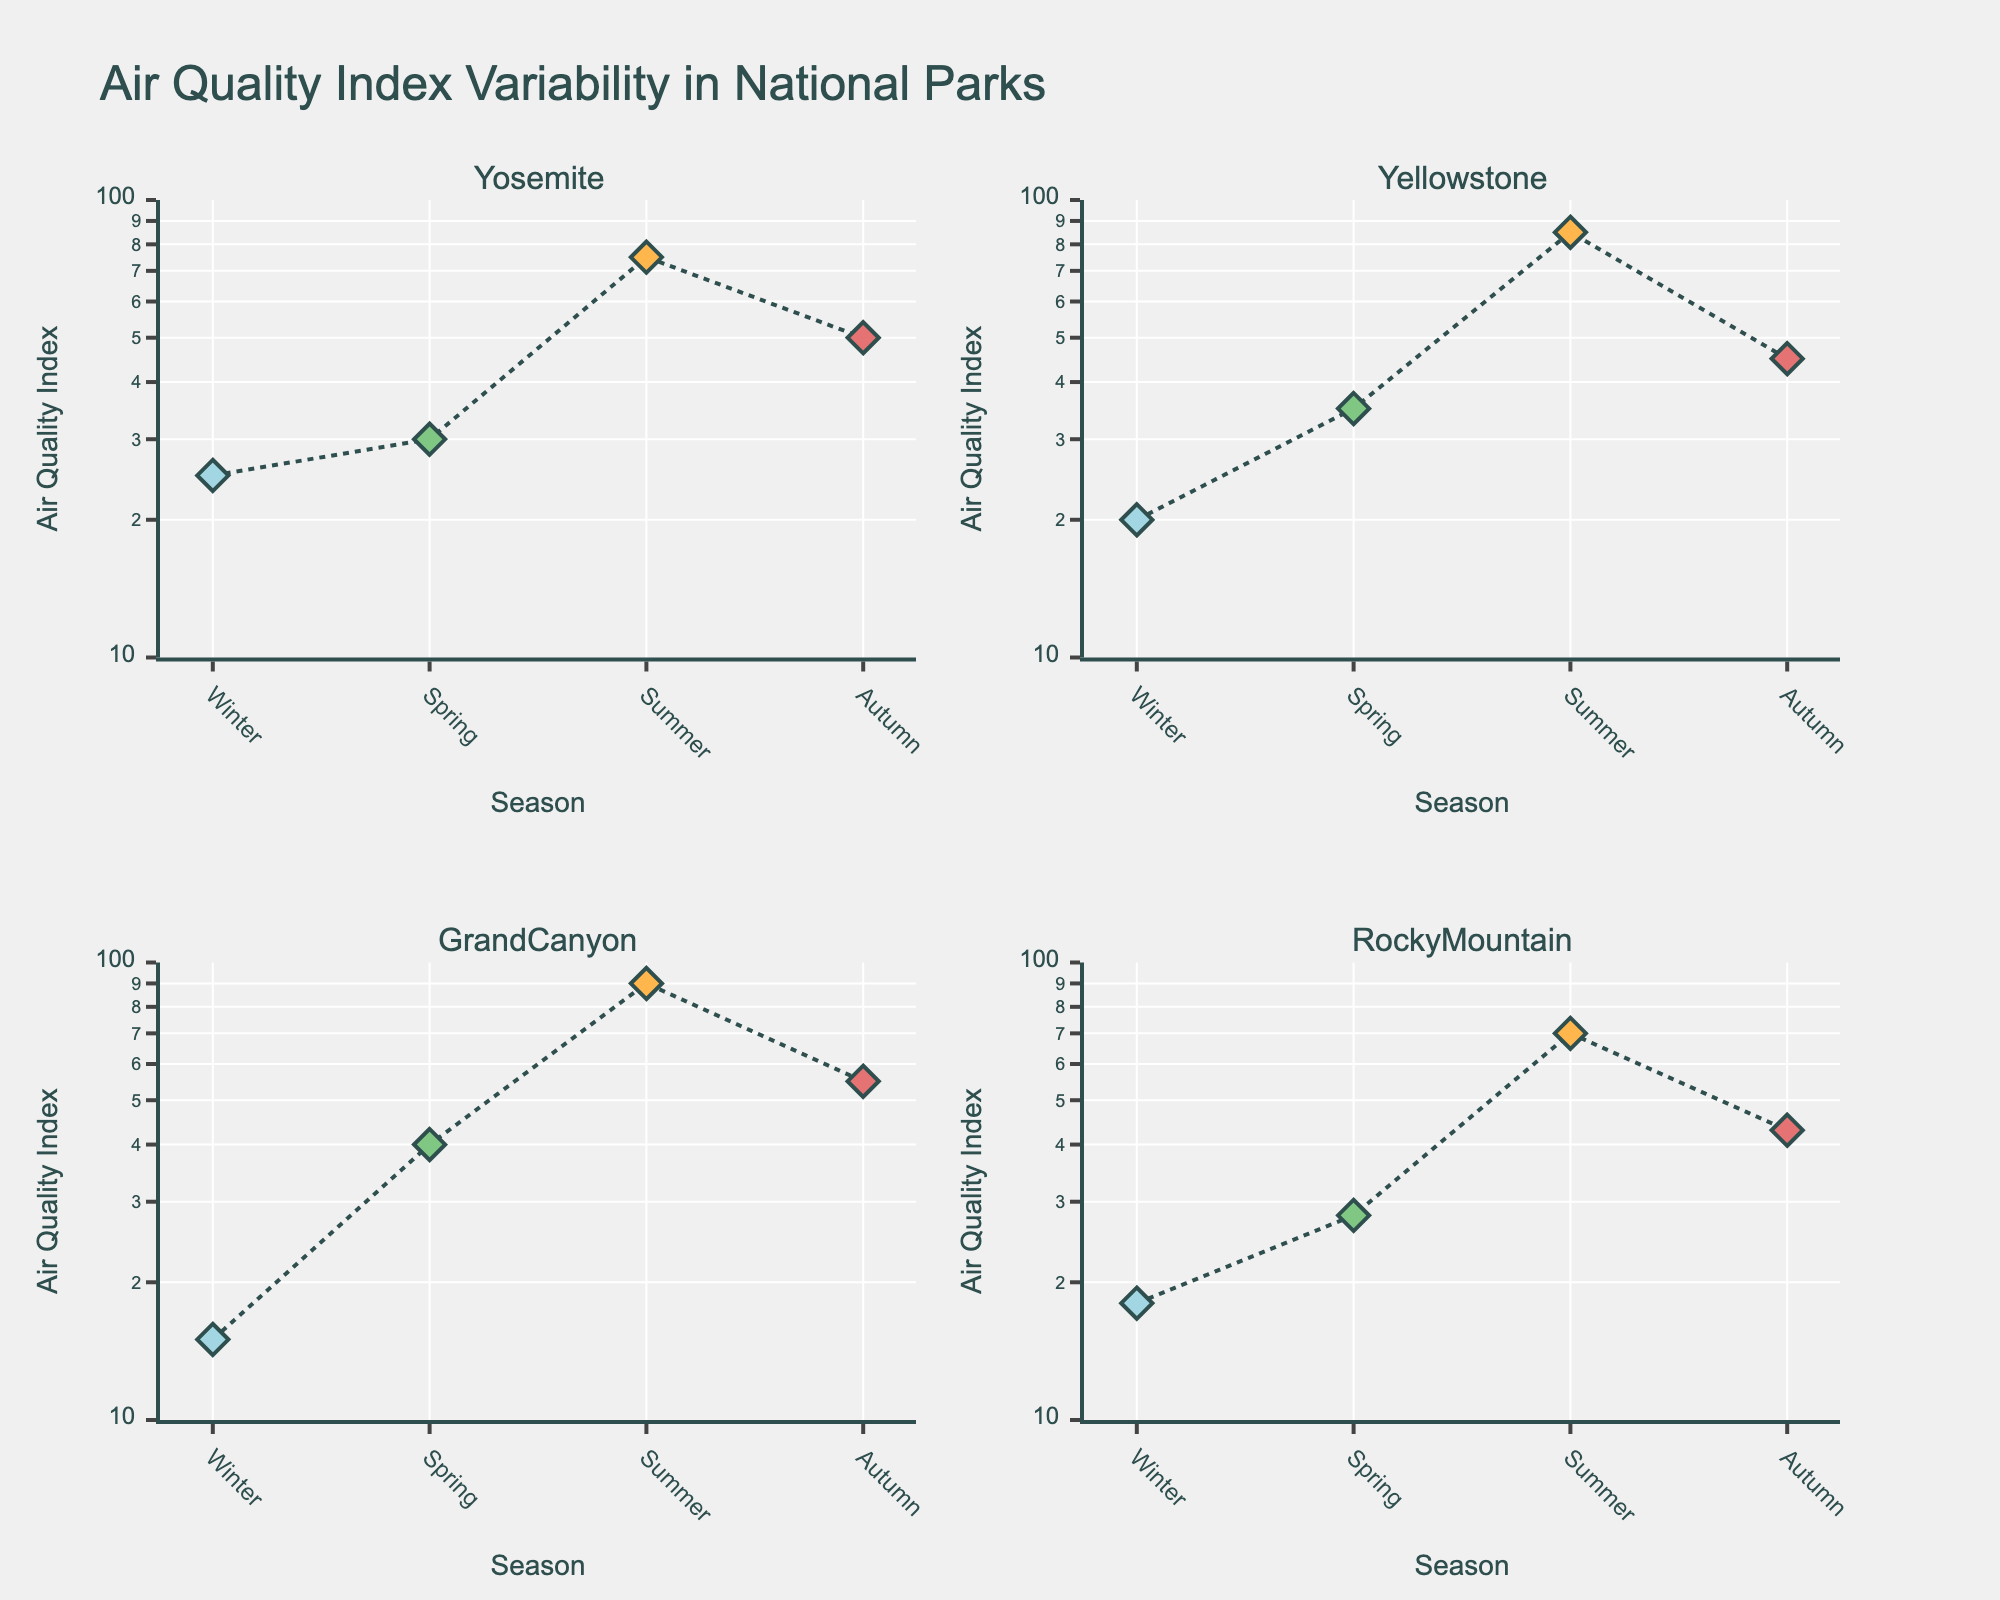What is the title of the figure? The title of the figure is usually found at the top of the plot; it provides a summary of what the figure is about. Here, it is "Air Quality Index Variability in National Parks".
Answer: Air Quality Index Variability in National Parks What are the x-axis and y-axis labels? The x-axis label is "Season" and the y-axis label is "Air Quality Index". This can be identified by checking the axes' titles usually located near or on the axes themselves.
Answer: Season and Air Quality Index Which season shows the highest Air Quality Index in Yosemite? To answer this, look at the plot for Yosemite and find which data point (seasons: Winter, Spring, Summer, Autumn) has the highest value on the y-axis. The highest point is in Summer.
Answer: Summer Rank the parks from lowest to highest based on their Air Quality Index during Winter. Analyze each subplot to identify Winter's Air Quality Index for each park, then arrange these values. Grand Canyon (15), Rocky Mountain (18), Yellowstone (20), Yosemite (25).
Answer: Grand Canyon, Rocky Mountain, Yellowstone, Yosemite Which park has the most significant increase in Air Quality Index from Spring to Summer? For each park's subplot, calculate the difference between the Spring and Summer values, then find the park with the highest difference. Grand Canyon has the most significant increase (90 - 40 = 50).
Answer: Grand Canyon Compare the Air Quality Index range for Rocky Mountain across seasons. Is it more or less variable than Yellowstone's? Calculate the range by subtracting the minimum value from the maximum for each park: Rocky Mountain (70 - 18 = 52), Yellowstone (85 - 20 = 65). Rocky Mountain has a smaller range, thus is less variable.
Answer: Less variable What range is used for the y-axis in the figure? The range for the y-axis is determined by the min and max marked on the axis. Here, it spans from log10(10) to log10(100).
Answer: log10(10) to log10(100) What color is used to represent the Summer season? Each season is represented by a different color. The color for Summer is identified as '#FFB74D', which is commonly visualized as an orange-like hue.
Answer: Orange What pattern is indicated by the line connecting data points? The line pattern connecting data points in each subplot is "dot", which signifies that the lines are dotted rather than solid or dashed.
Answer: Dotted Which park has the lowest Air Quality Index value across all seasons? Review each subplot and identify the lowest points. The lowest value across all seasons is 15 in the Grand Canyon during Winter.
Answer: Grand Canyon 